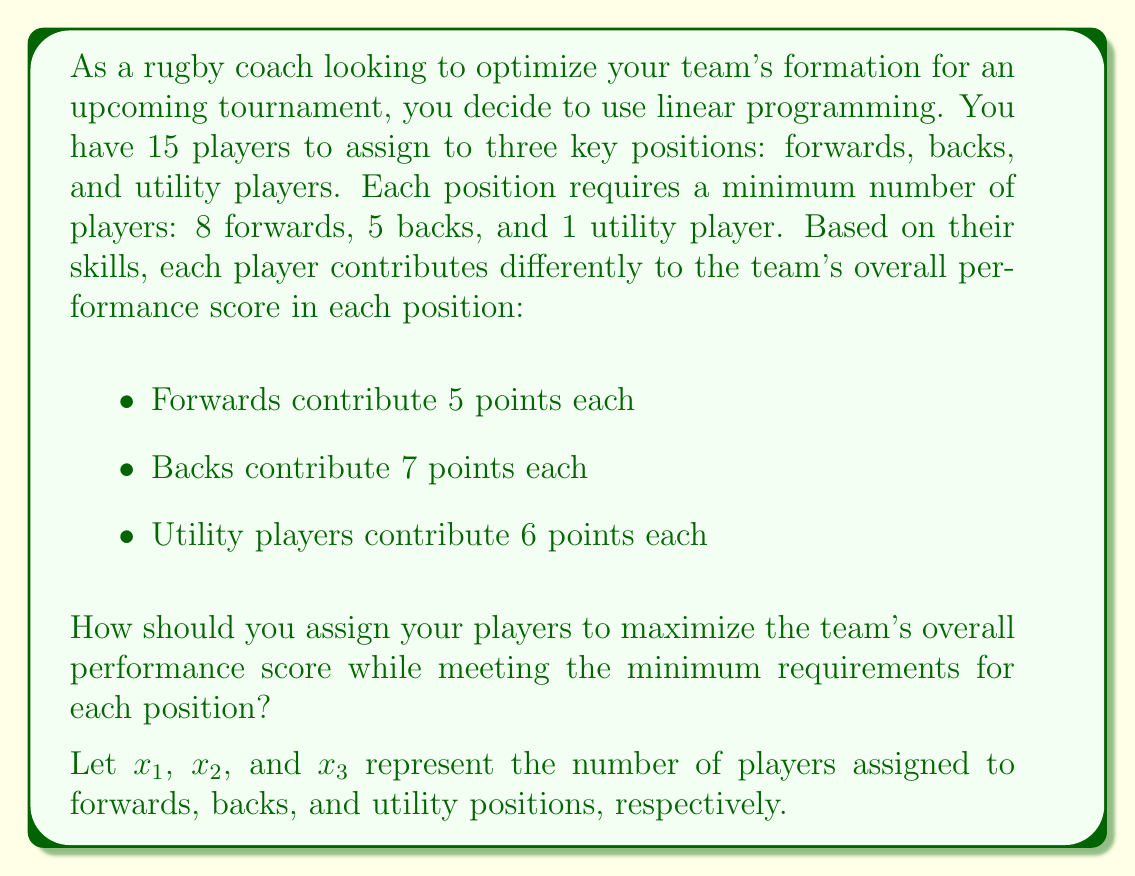Give your solution to this math problem. To solve this problem using linear programming, we need to set up the objective function and constraints:

Objective function (maximize):
$$ 5x_1 + 7x_2 + 6x_3 $$

Constraints:
1. Total number of players: $x_1 + x_2 + x_3 = 15$
2. Minimum number of forwards: $x_1 \geq 8$
3. Minimum number of backs: $x_2 \geq 5$
4. Minimum number of utility players: $x_3 \geq 1$
5. Non-negativity: $x_1, x_2, x_3 \geq 0$

We can solve this using the simplex method or a linear programming solver. However, we can also reason through the solution:

1. We must meet the minimum requirements first:
   8 forwards, 5 backs, and 1 utility player (total 14 players)

2. We have one player left to assign. To maximize the score, we should assign this player to the position with the highest contribution:
   Backs contribute 7 points, which is the highest.

Therefore, the optimal assignment is:
- 8 forwards
- 6 backs
- 1 utility player

We can verify that this satisfies all constraints and maximizes the objective function.
Answer: The optimal team formation is:
- 8 forwards ($x_1 = 8$)
- 6 backs ($x_2 = 6$)
- 1 utility player ($x_3 = 1$)

The maximum performance score is:
$$ 5(8) + 7(6) + 6(1) = 40 + 42 + 6 = 88 \text{ points} $$ 